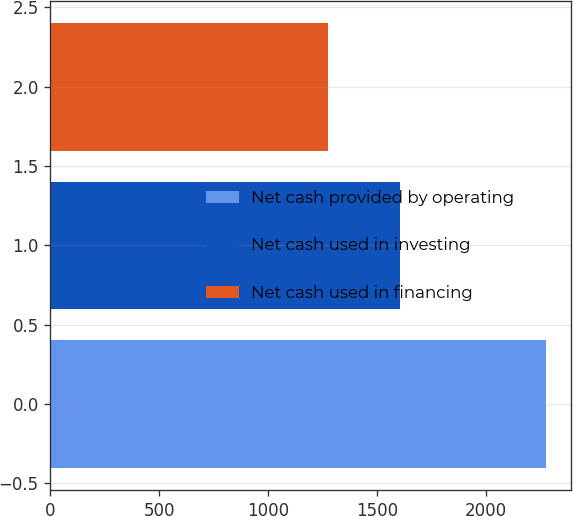<chart> <loc_0><loc_0><loc_500><loc_500><bar_chart><fcel>Net cash provided by operating<fcel>Net cash used in investing<fcel>Net cash used in financing<nl><fcel>2275<fcel>1606<fcel>1273<nl></chart> 